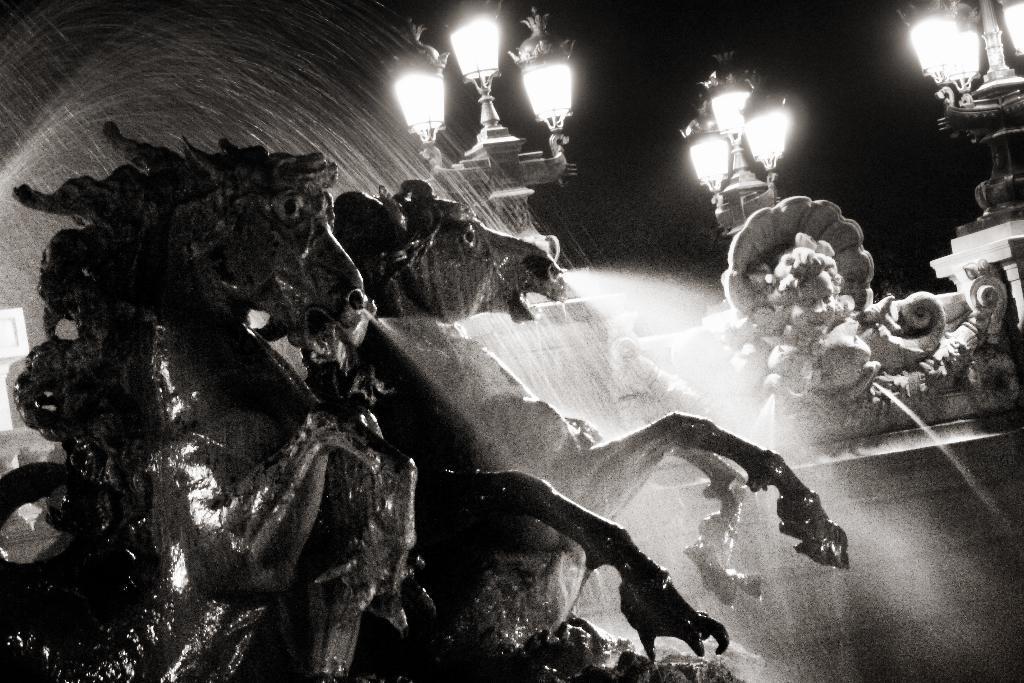In one or two sentences, can you explain what this image depicts? In this image we can see sculptures and a wall. Behind the sculptures we can see lamps and water. The background of the image is dark. 